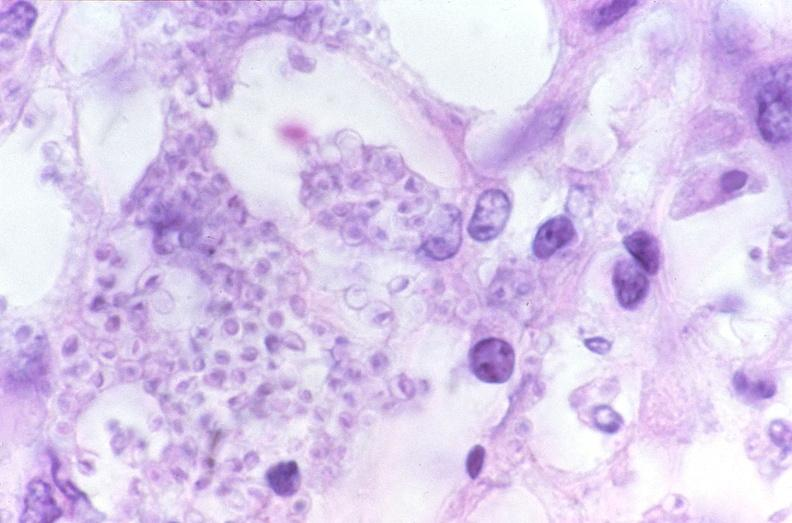does this image show lung, histoplasma pneumonia?
Answer the question using a single word or phrase. Yes 